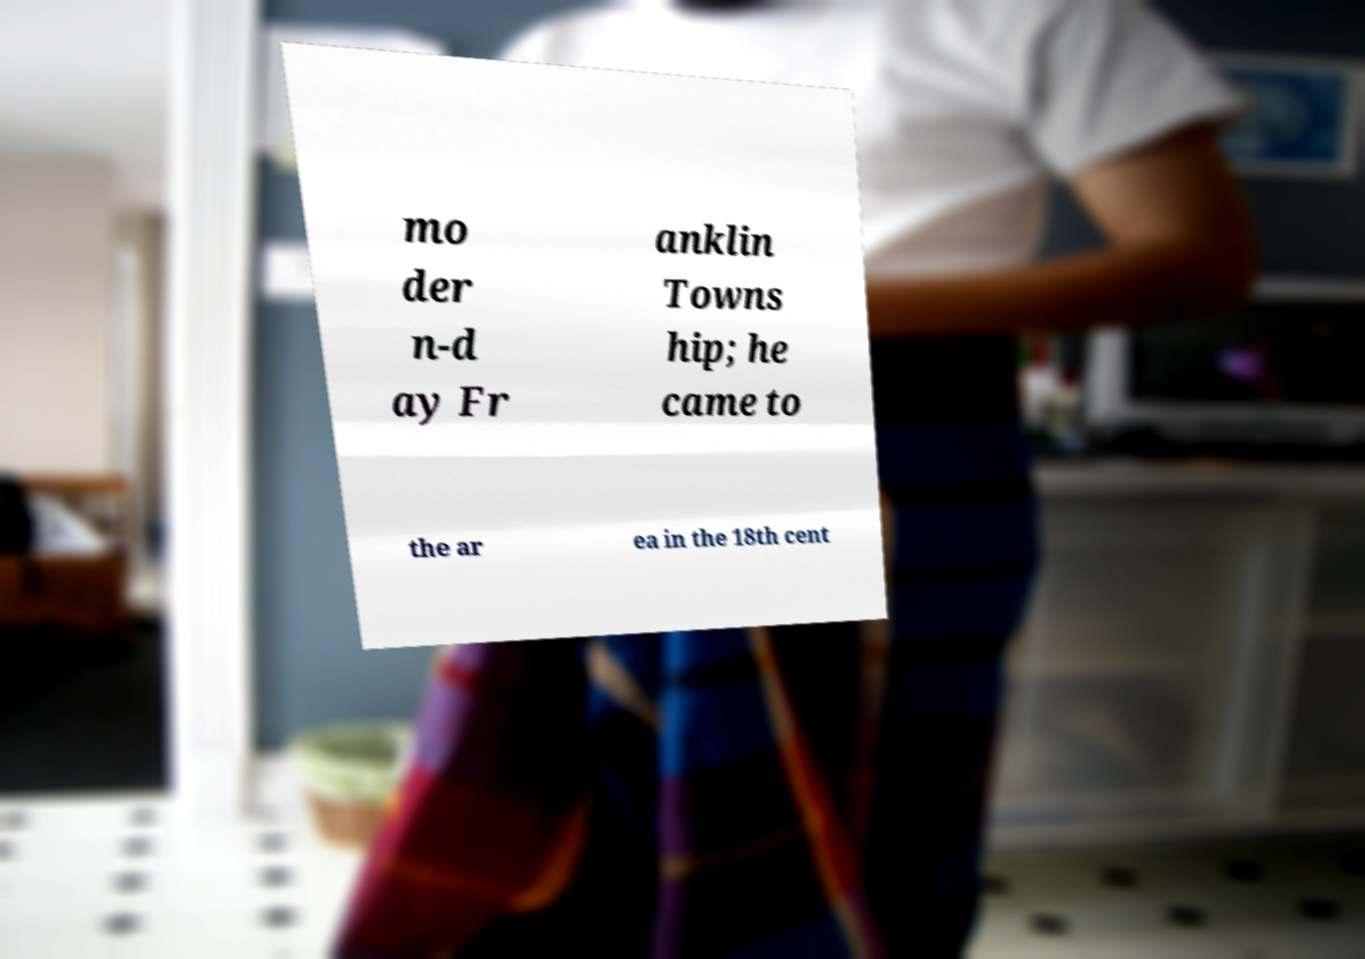Please identify and transcribe the text found in this image. mo der n-d ay Fr anklin Towns hip; he came to the ar ea in the 18th cent 